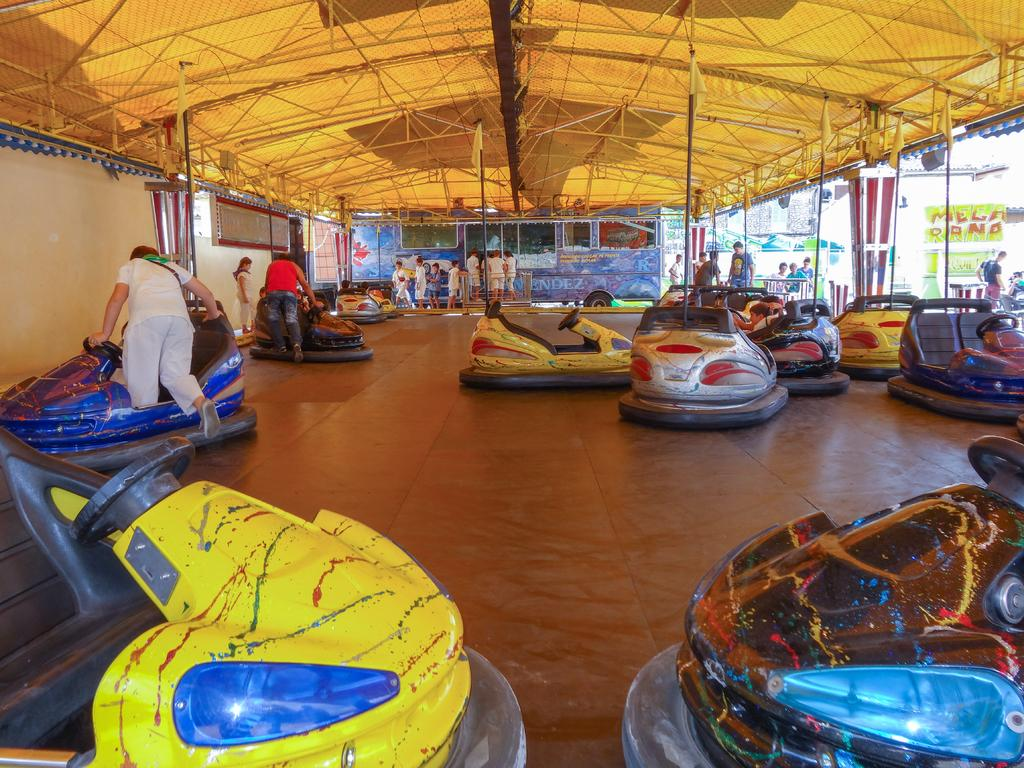What type of vehicles are in the image? There are colorful cars in the image. What is the color of the surface the cars are on? The surface they are on is brown. Can you describe the people in the image? There are people in the image, but their specific characteristics are not mentioned in the facts. What can be seen attached to poles in the image? There are flags and banners in the image. What other objects are present in the image? There are boards and a vehicle in the image. What is above the scene in the image? There is a ceiling in the image. What is the purpose of the ghost in the image? There is no ghost present in the image. How does the spark affect the cars in the image? There is no spark present in the image. 